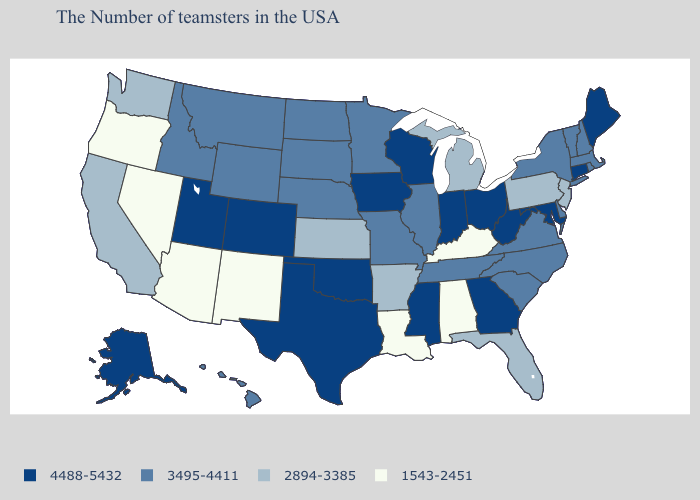Does Arkansas have the same value as Oregon?
Keep it brief. No. Name the states that have a value in the range 4488-5432?
Keep it brief. Maine, Connecticut, Maryland, West Virginia, Ohio, Georgia, Indiana, Wisconsin, Mississippi, Iowa, Oklahoma, Texas, Colorado, Utah, Alaska. Which states hav the highest value in the West?
Keep it brief. Colorado, Utah, Alaska. Name the states that have a value in the range 2894-3385?
Give a very brief answer. New Jersey, Pennsylvania, Florida, Michigan, Arkansas, Kansas, California, Washington. What is the highest value in the West ?
Keep it brief. 4488-5432. Name the states that have a value in the range 4488-5432?
Answer briefly. Maine, Connecticut, Maryland, West Virginia, Ohio, Georgia, Indiana, Wisconsin, Mississippi, Iowa, Oklahoma, Texas, Colorado, Utah, Alaska. Does the map have missing data?
Short answer required. No. Is the legend a continuous bar?
Quick response, please. No. Among the states that border Wisconsin , does Minnesota have the lowest value?
Short answer required. No. What is the highest value in states that border Vermont?
Short answer required. 3495-4411. Which states hav the highest value in the South?
Write a very short answer. Maryland, West Virginia, Georgia, Mississippi, Oklahoma, Texas. Does Louisiana have the same value as Kentucky?
Short answer required. Yes. Does South Dakota have the highest value in the MidWest?
Be succinct. No. Does Maine have the highest value in the Northeast?
Write a very short answer. Yes. Does Wisconsin have a lower value than New Mexico?
Concise answer only. No. 